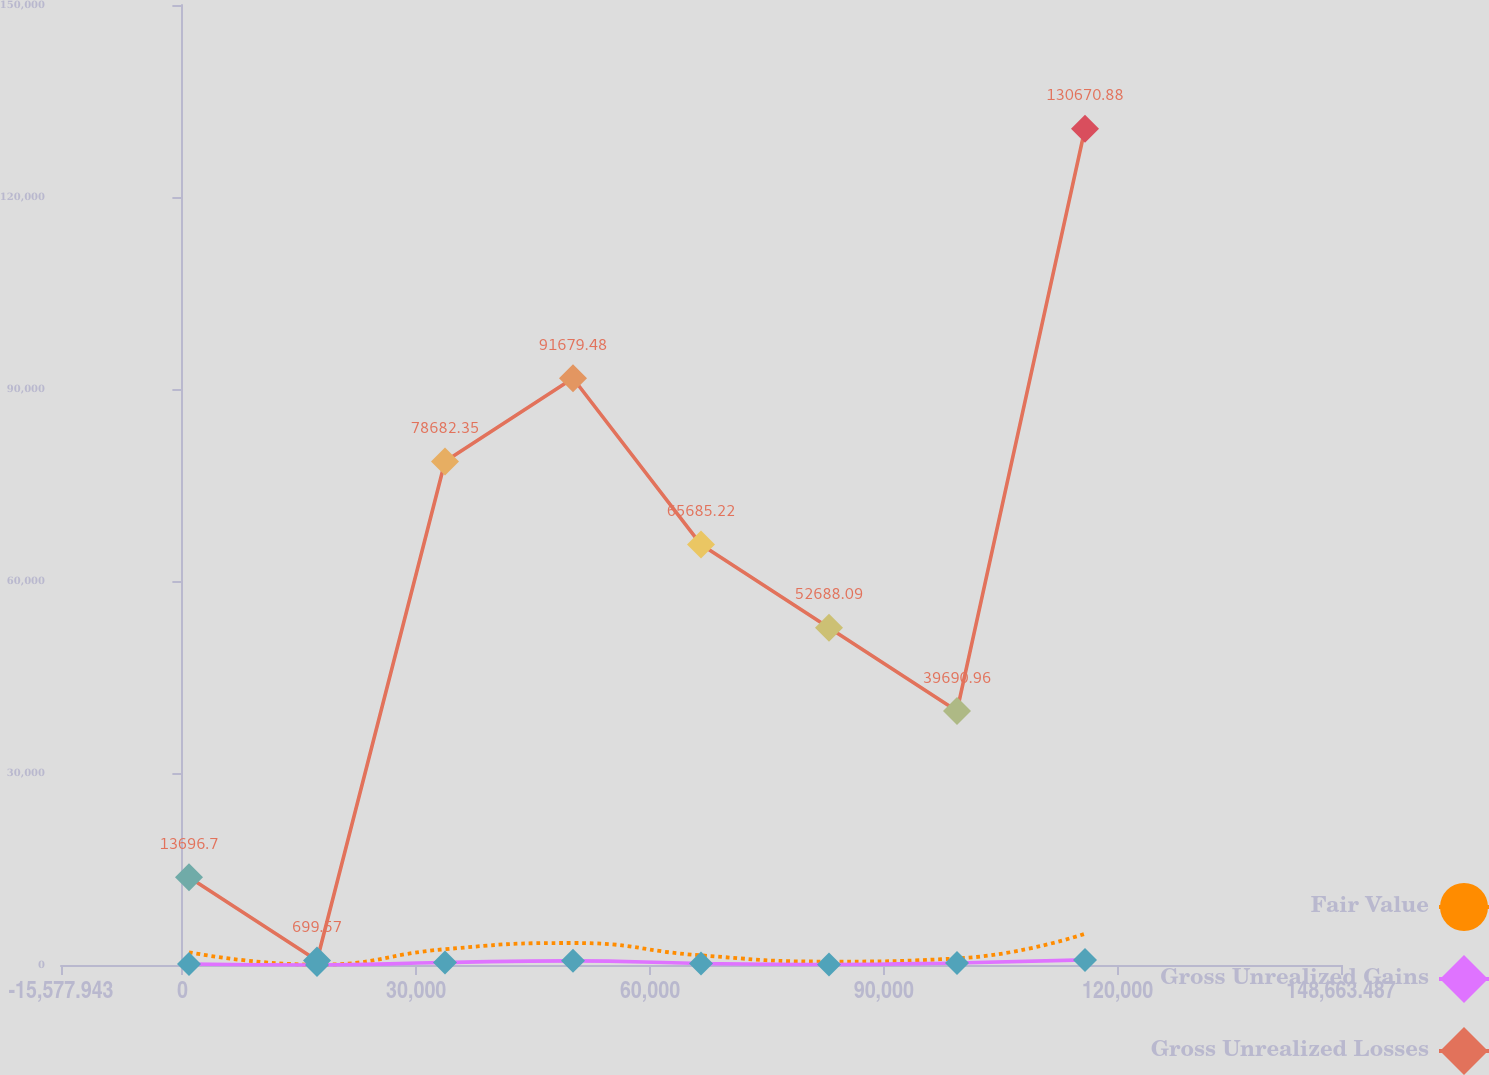Convert chart. <chart><loc_0><loc_0><loc_500><loc_500><line_chart><ecel><fcel>Fair Value<fcel>Gross Unrealized Gains<fcel>Gross Unrealized Losses<nl><fcel>846.2<fcel>1987.39<fcel>161.11<fcel>13696.7<nl><fcel>17270.3<fcel>54.91<fcel>1.95<fcel>699.57<nl><fcel>33694.5<fcel>2470.51<fcel>399.85<fcel>78682.4<nl><fcel>50118.6<fcel>3436.75<fcel>647.15<fcel>91679.5<nl><fcel>66542.8<fcel>1504.27<fcel>240.69<fcel>65685.2<nl><fcel>82966.9<fcel>538.03<fcel>81.53<fcel>52688.1<nl><fcel>99391<fcel>1021.15<fcel>320.27<fcel>39691<nl><fcel>115815<fcel>4886.08<fcel>797.77<fcel>130671<nl><fcel>165088<fcel>2953.63<fcel>479.43<fcel>26693.8<nl></chart> 